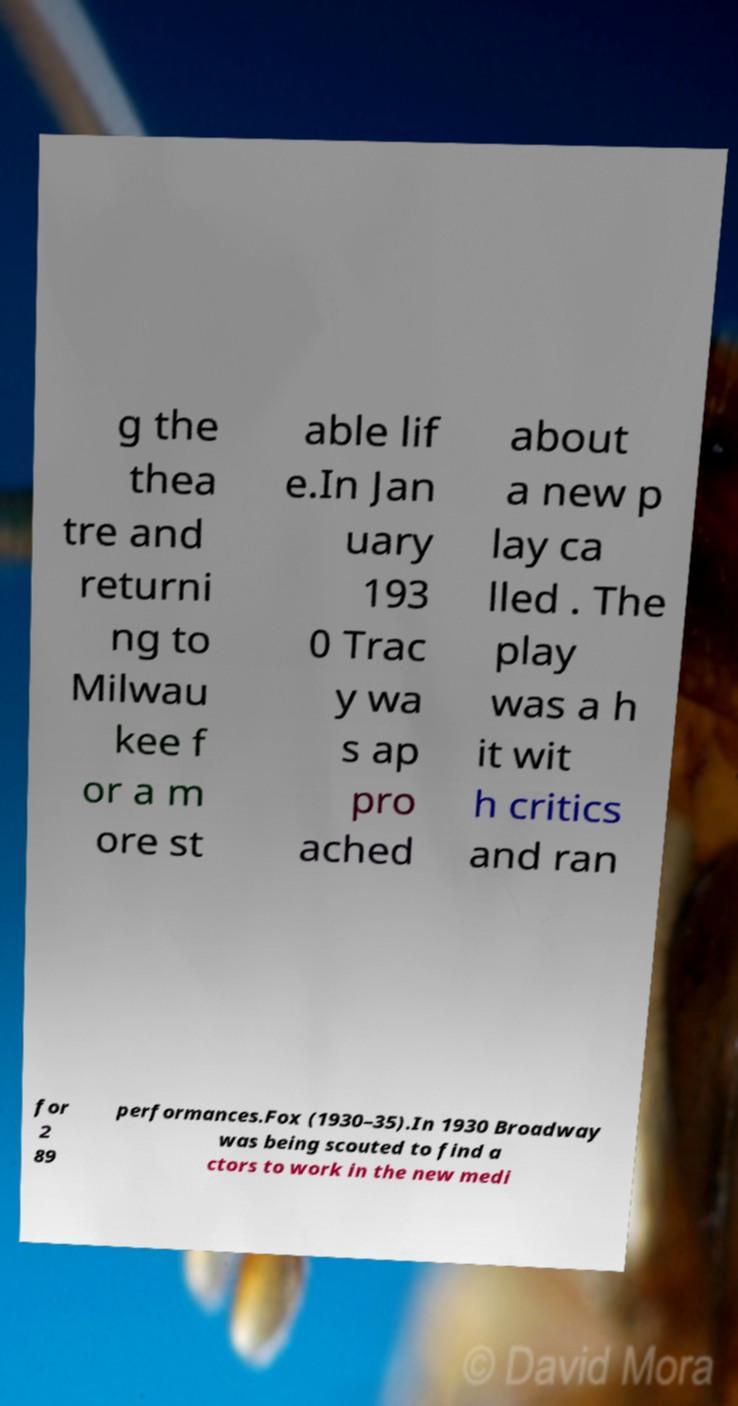For documentation purposes, I need the text within this image transcribed. Could you provide that? g the thea tre and returni ng to Milwau kee f or a m ore st able lif e.In Jan uary 193 0 Trac y wa s ap pro ached about a new p lay ca lled . The play was a h it wit h critics and ran for 2 89 performances.Fox (1930–35).In 1930 Broadway was being scouted to find a ctors to work in the new medi 